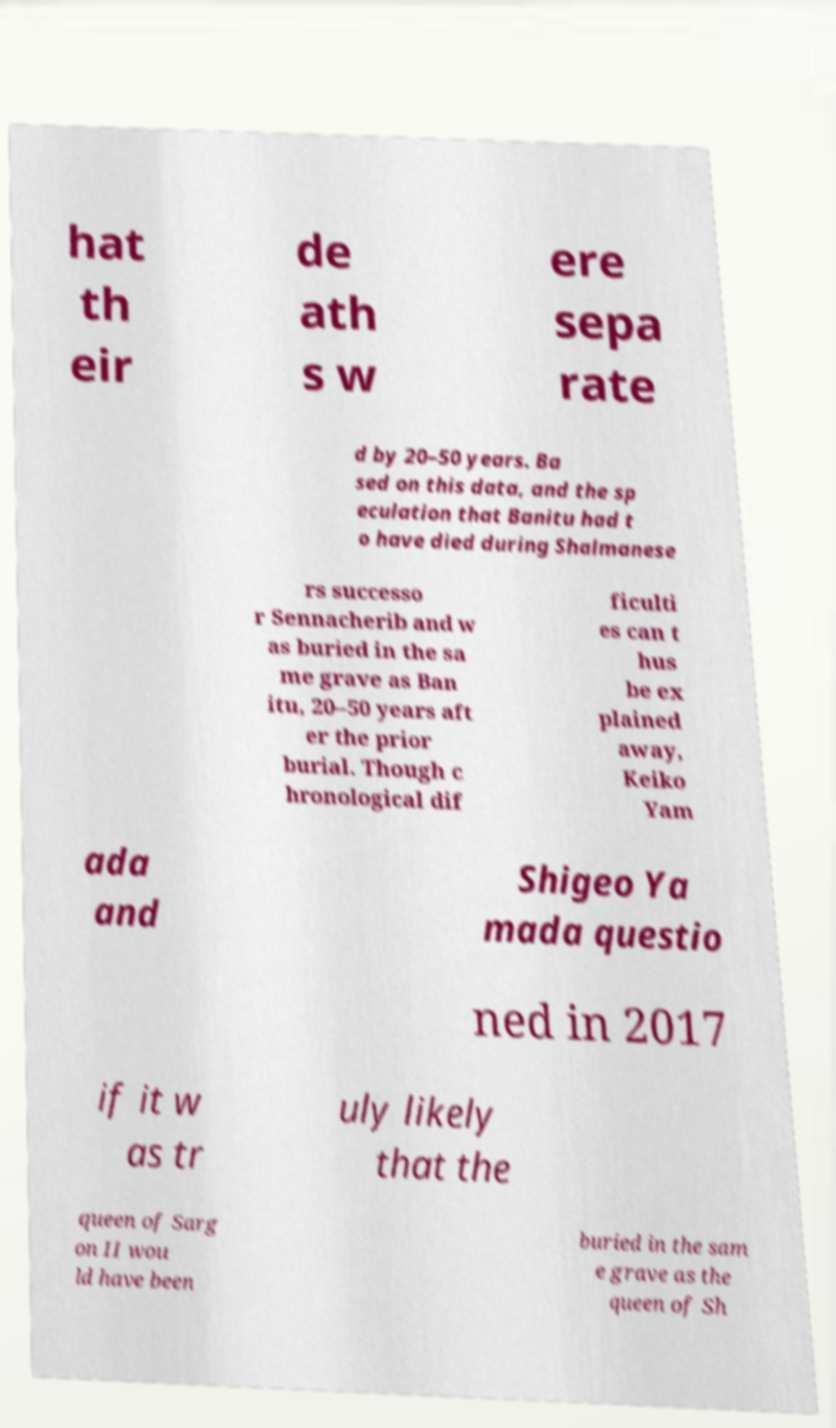Can you read and provide the text displayed in the image?This photo seems to have some interesting text. Can you extract and type it out for me? hat th eir de ath s w ere sepa rate d by 20–50 years. Ba sed on this data, and the sp eculation that Banitu had t o have died during Shalmanese rs successo r Sennacherib and w as buried in the sa me grave as Ban itu, 20–50 years aft er the prior burial. Though c hronological dif ficulti es can t hus be ex plained away, Keiko Yam ada and Shigeo Ya mada questio ned in 2017 if it w as tr uly likely that the queen of Sarg on II wou ld have been buried in the sam e grave as the queen of Sh 